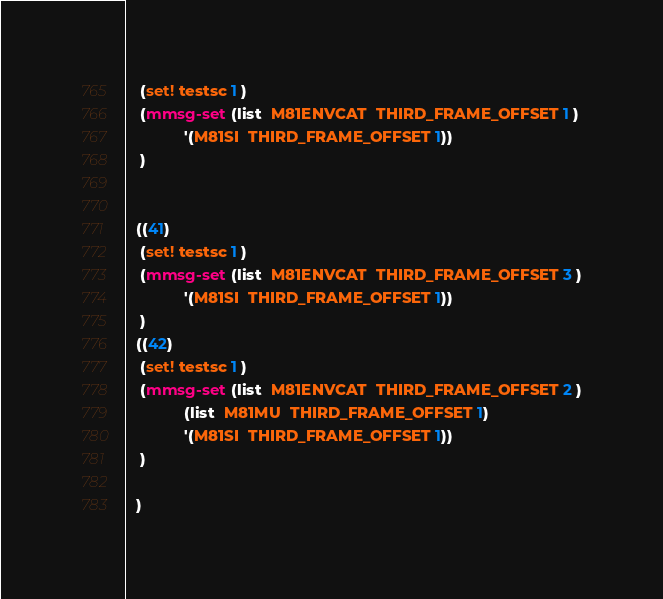<code> <loc_0><loc_0><loc_500><loc_500><_Scheme_>   (set! testsc 1 )
   (mmsg-set (list  M81ENVCAT  THIRD_FRAME_OFFSET 1 )
             '(M81SI  THIRD_FRAME_OFFSET 1))
   )

  
  ((41)
   (set! testsc 1 )
   (mmsg-set (list  M81ENVCAT  THIRD_FRAME_OFFSET 3 )
             '(M81SI  THIRD_FRAME_OFFSET 1))
   )
  ((42)
   (set! testsc 1 )
   (mmsg-set (list  M81ENVCAT  THIRD_FRAME_OFFSET 2 )
             (list  M81MU  THIRD_FRAME_OFFSET 1)
             '(M81SI  THIRD_FRAME_OFFSET 1))
   )
  
  )

</code> 